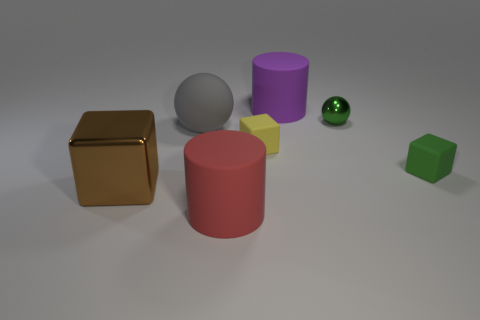Do the metal object to the right of the large gray object and the big gray thing have the same shape?
Offer a very short reply. Yes. Does the red cylinder have the same size as the thing on the right side of the small green shiny sphere?
Keep it short and to the point. No. How many other things are there of the same color as the large shiny object?
Offer a terse response. 0. There is a red rubber cylinder; are there any things right of it?
Give a very brief answer. Yes. How many objects are either brown metallic cubes or spheres that are right of the large red matte cylinder?
Provide a short and direct response. 2. There is a big red matte thing on the right side of the large metallic thing; is there a large matte cylinder to the right of it?
Offer a terse response. Yes. The tiny matte thing left of the small cube on the right side of the tiny thing that is behind the big rubber sphere is what shape?
Your response must be concise. Cube. There is a block that is both in front of the yellow rubber cube and on the right side of the brown shiny object; what is its color?
Ensure brevity in your answer.  Green. There is a shiny object to the left of the red matte cylinder; what is its shape?
Give a very brief answer. Cube. What is the shape of the big purple object that is made of the same material as the red cylinder?
Your answer should be very brief. Cylinder. 